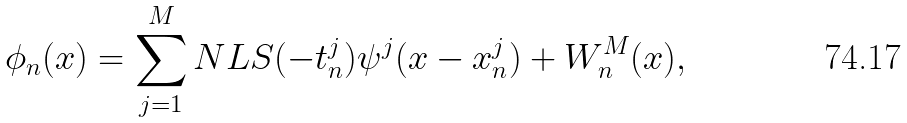Convert formula to latex. <formula><loc_0><loc_0><loc_500><loc_500>\phi _ { n } ( x ) = \sum _ { j = 1 } ^ { M } N L S ( - t _ { n } ^ { j } ) \psi ^ { j } ( x - x _ { n } ^ { j } ) + W _ { n } ^ { M } ( x ) ,</formula> 